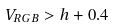<formula> <loc_0><loc_0><loc_500><loc_500>V _ { R G B } > h + 0 . 4</formula> 